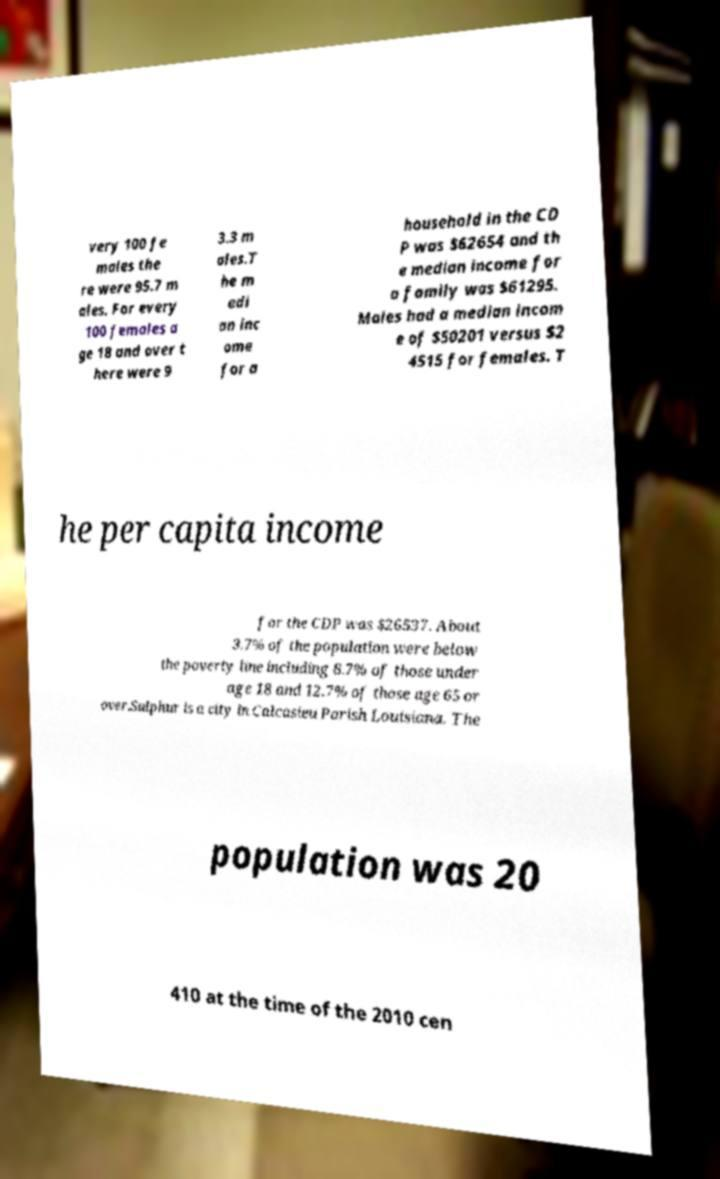I need the written content from this picture converted into text. Can you do that? very 100 fe males the re were 95.7 m ales. For every 100 females a ge 18 and over t here were 9 3.3 m ales.T he m edi an inc ome for a household in the CD P was $62654 and th e median income for a family was $61295. Males had a median incom e of $50201 versus $2 4515 for females. T he per capita income for the CDP was $26537. About 3.7% of the population were below the poverty line including 8.7% of those under age 18 and 12.7% of those age 65 or over.Sulphur is a city in Calcasieu Parish Louisiana. The population was 20 410 at the time of the 2010 cen 